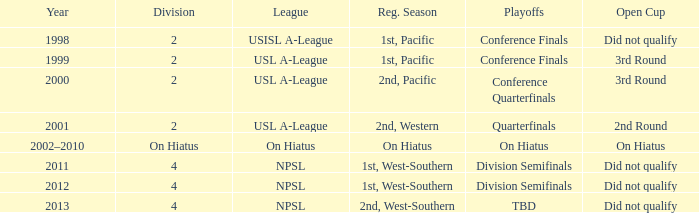When did the usl a-league have conference finals? 1999.0. 